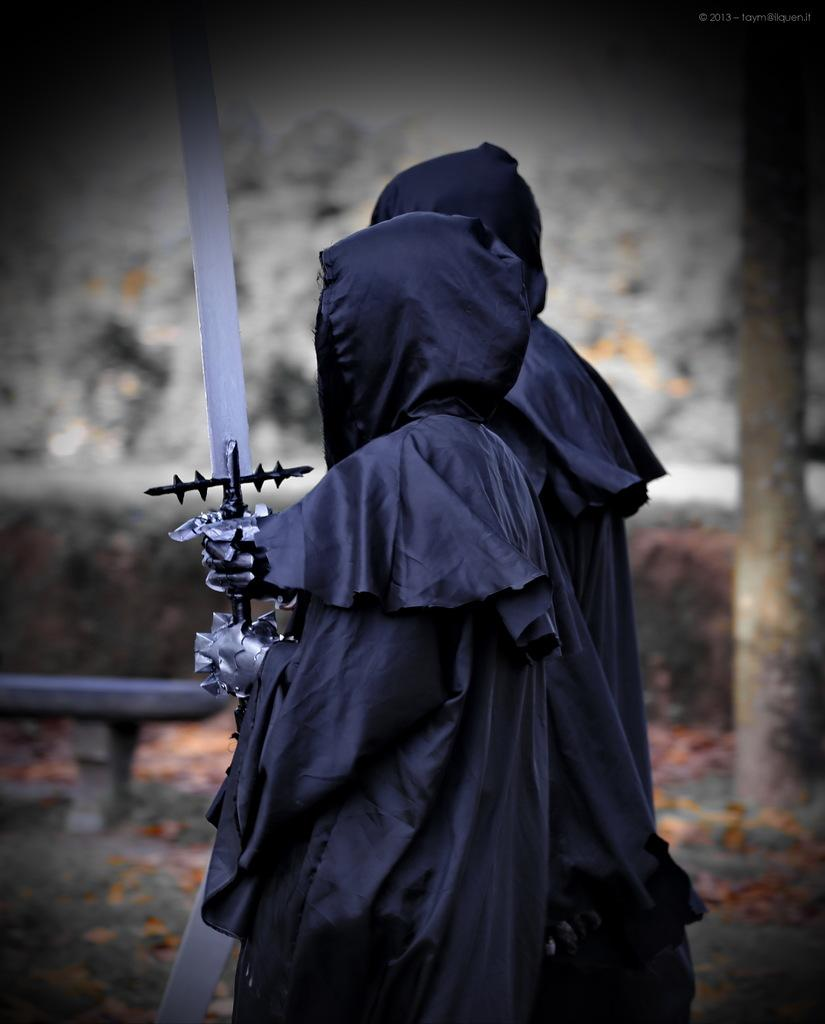How many people are in the image? There are two persons in the image. What is one of the persons holding in their hands? One person is holding a sword in their hands. Can you describe the background of the image? The background of the image is blurry. What type of police system is being discussed in the image? There is no reference to a police system or any discussion in the image; it features two persons, one of whom is holding a sword. 